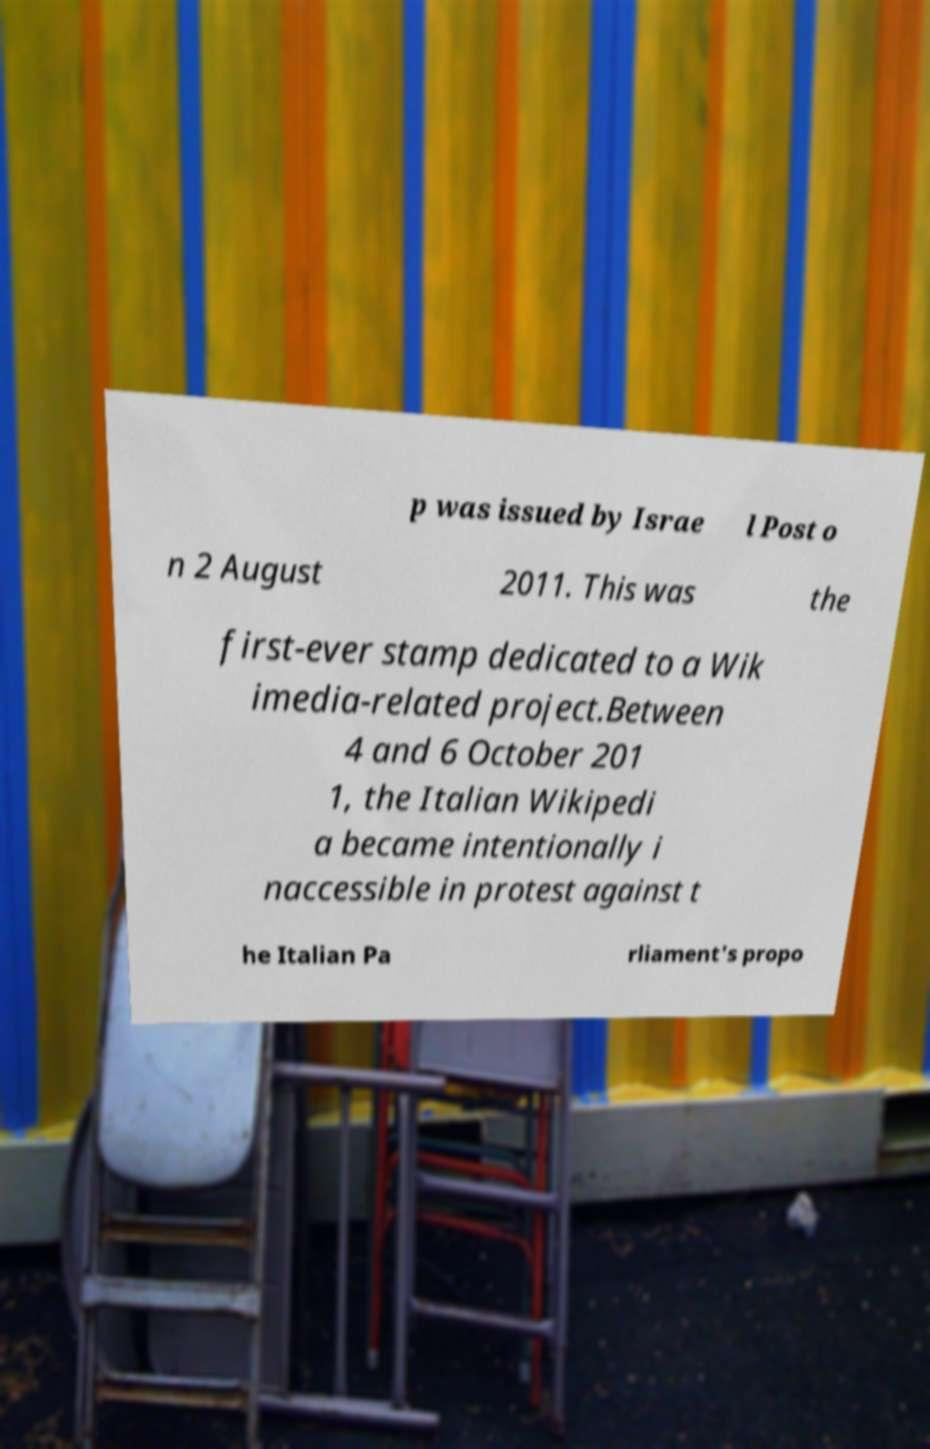What messages or text are displayed in this image? I need them in a readable, typed format. p was issued by Israe l Post o n 2 August 2011. This was the first-ever stamp dedicated to a Wik imedia-related project.Between 4 and 6 October 201 1, the Italian Wikipedi a became intentionally i naccessible in protest against t he Italian Pa rliament's propo 